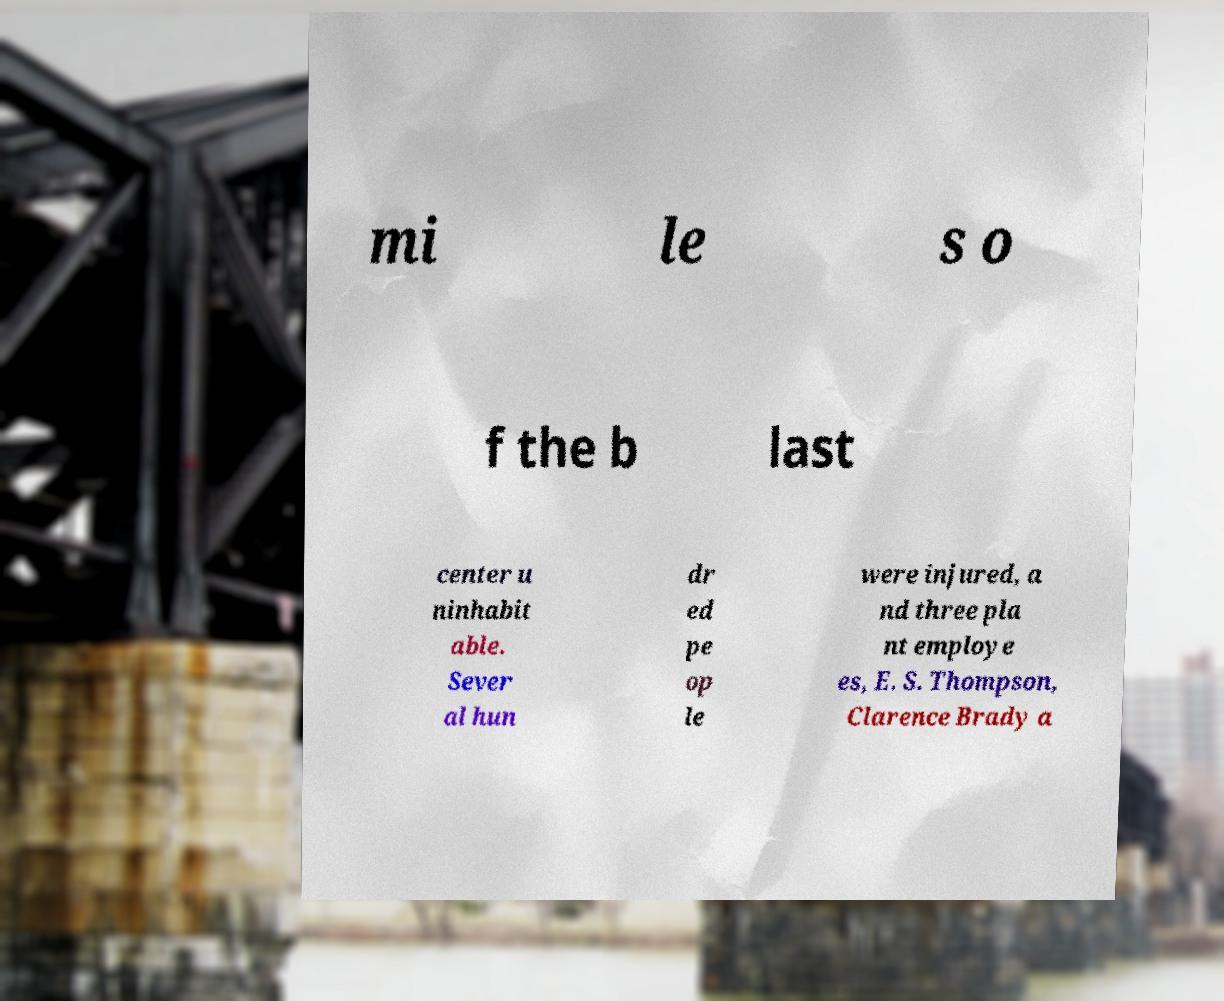Please identify and transcribe the text found in this image. mi le s o f the b last center u ninhabit able. Sever al hun dr ed pe op le were injured, a nd three pla nt employe es, E. S. Thompson, Clarence Brady a 